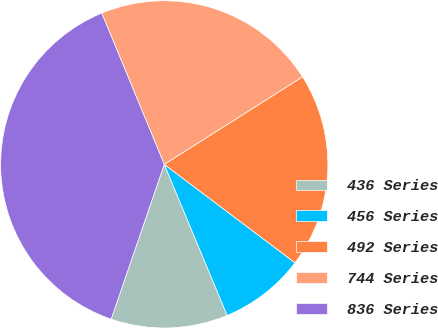<chart> <loc_0><loc_0><loc_500><loc_500><pie_chart><fcel>436 Series<fcel>456 Series<fcel>492 Series<fcel>744 Series<fcel>836 Series<nl><fcel>11.54%<fcel>8.45%<fcel>19.25%<fcel>22.26%<fcel>38.5%<nl></chart> 